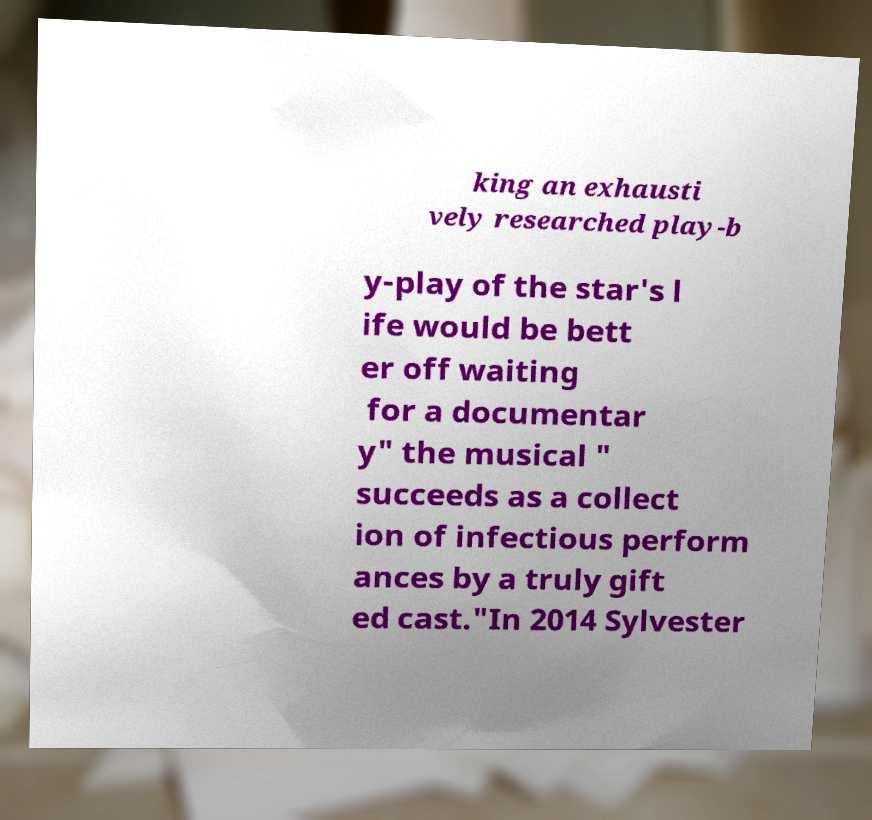For documentation purposes, I need the text within this image transcribed. Could you provide that? king an exhausti vely researched play-b y-play of the star's l ife would be bett er off waiting for a documentar y" the musical " succeeds as a collect ion of infectious perform ances by a truly gift ed cast."In 2014 Sylvester 